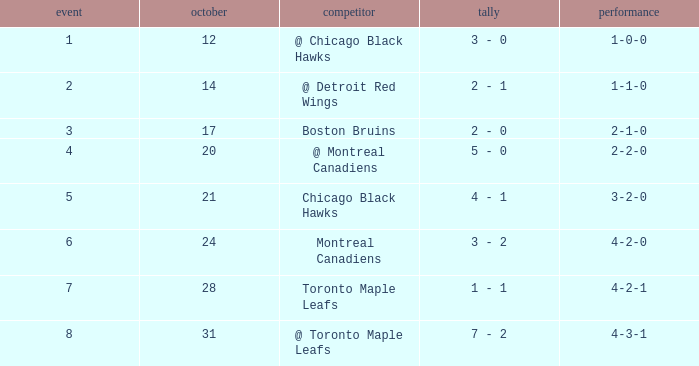What was the record for the game before game 6 against the chicago black hawks? 3-2-0. 